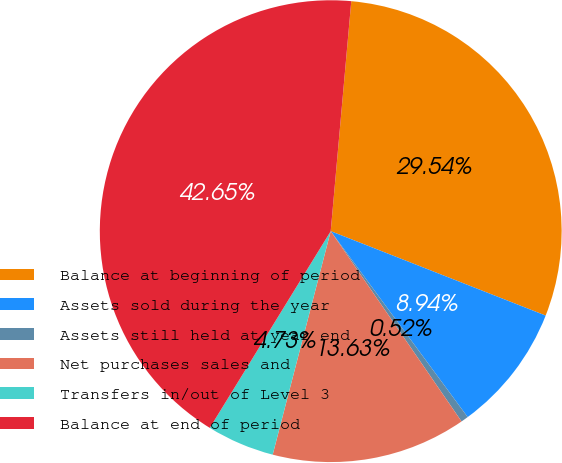Convert chart to OTSL. <chart><loc_0><loc_0><loc_500><loc_500><pie_chart><fcel>Balance at beginning of period<fcel>Assets sold during the year<fcel>Assets still held at year end<fcel>Net purchases sales and<fcel>Transfers in/out of Level 3<fcel>Balance at end of period<nl><fcel>29.54%<fcel>8.94%<fcel>0.52%<fcel>13.63%<fcel>4.73%<fcel>42.65%<nl></chart> 